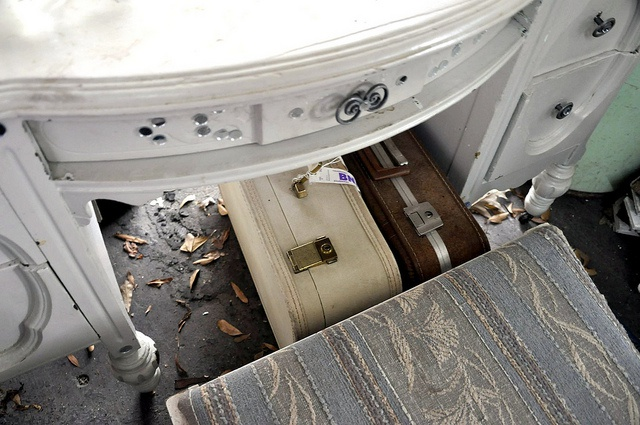Describe the objects in this image and their specific colors. I can see suitcase in lightgray, gray, and darkgray tones, suitcase in lightgray, tan, and gray tones, and suitcase in lightgray, black, and gray tones in this image. 